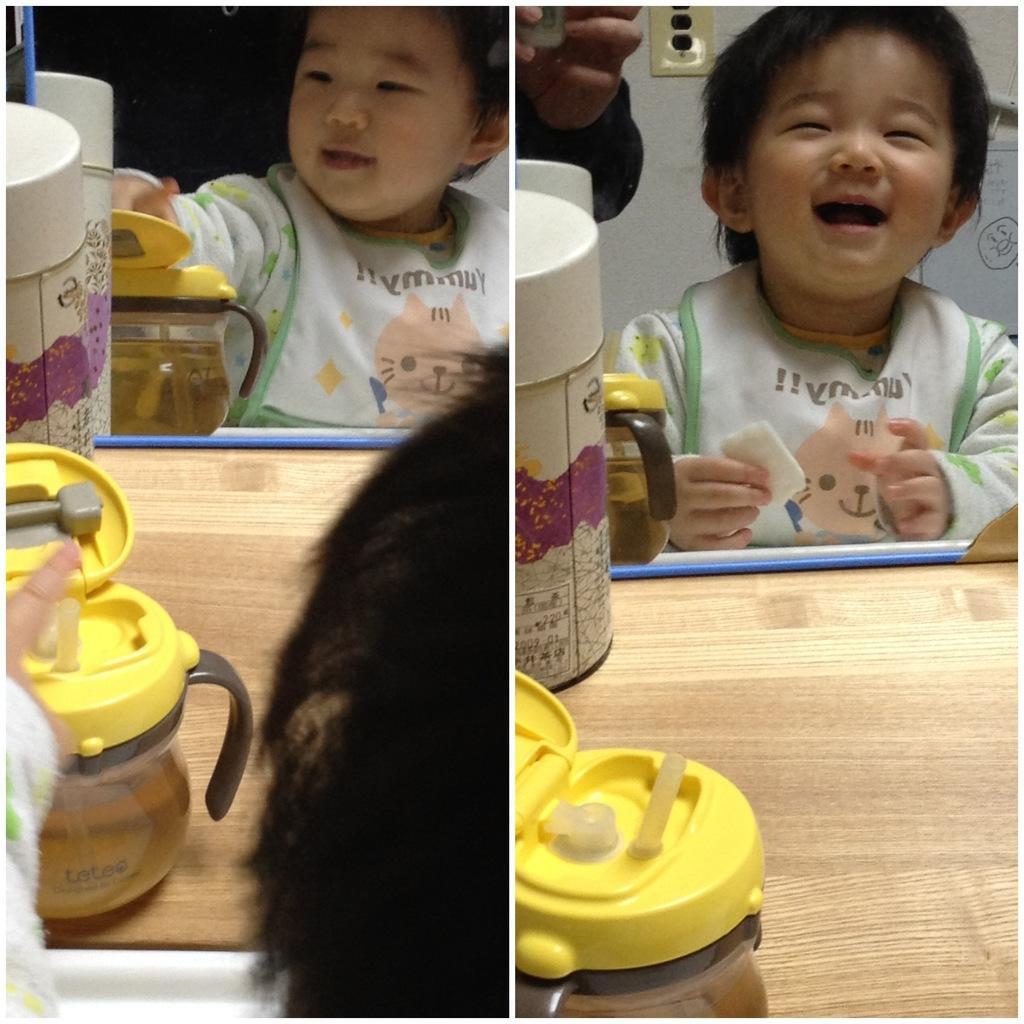How would you summarize this image in a sentence or two? In this image we can see a toddler sitting in front of the table and having some food. And we can see some some jars having food on the table. and we can see some person beside the toddler. 